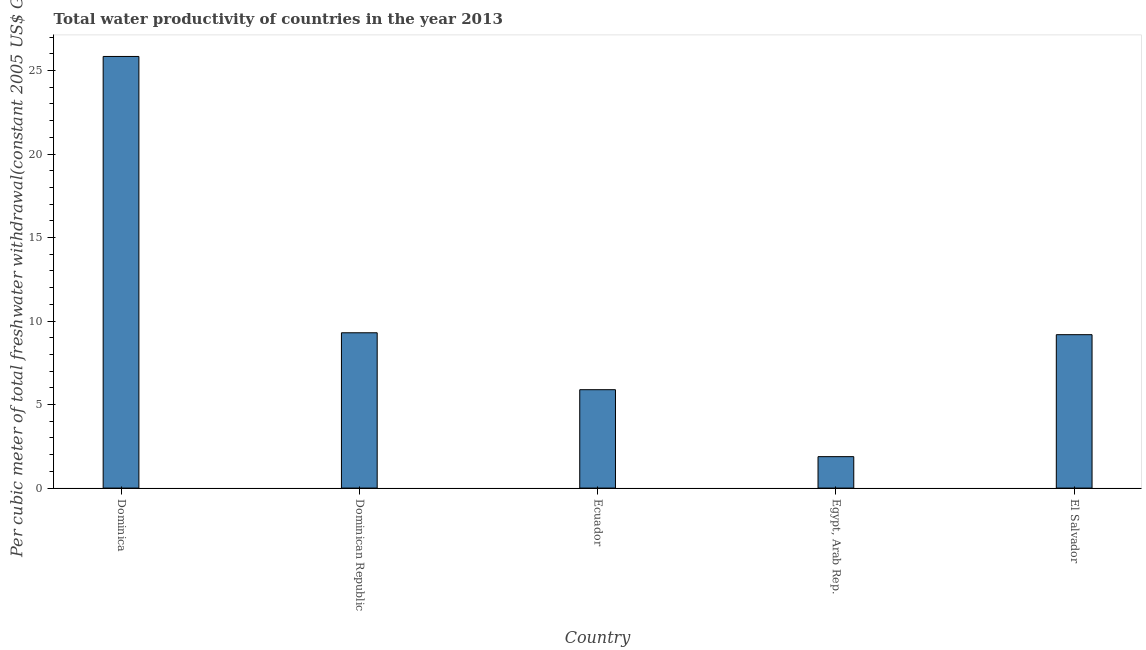Does the graph contain grids?
Your answer should be compact. No. What is the title of the graph?
Provide a succinct answer. Total water productivity of countries in the year 2013. What is the label or title of the Y-axis?
Your answer should be compact. Per cubic meter of total freshwater withdrawal(constant 2005 US$ GDP). What is the total water productivity in Egypt, Arab Rep.?
Make the answer very short. 1.88. Across all countries, what is the maximum total water productivity?
Give a very brief answer. 25.84. Across all countries, what is the minimum total water productivity?
Your answer should be compact. 1.88. In which country was the total water productivity maximum?
Offer a very short reply. Dominica. In which country was the total water productivity minimum?
Your response must be concise. Egypt, Arab Rep. What is the sum of the total water productivity?
Your response must be concise. 52.1. What is the difference between the total water productivity in Dominica and Dominican Republic?
Keep it short and to the point. 16.54. What is the average total water productivity per country?
Your answer should be very brief. 10.42. What is the median total water productivity?
Make the answer very short. 9.18. What is the ratio of the total water productivity in Ecuador to that in Egypt, Arab Rep.?
Provide a short and direct response. 3.13. Is the total water productivity in Dominican Republic less than that in Egypt, Arab Rep.?
Your answer should be compact. No. What is the difference between the highest and the second highest total water productivity?
Your answer should be compact. 16.54. What is the difference between the highest and the lowest total water productivity?
Give a very brief answer. 23.96. In how many countries, is the total water productivity greater than the average total water productivity taken over all countries?
Provide a short and direct response. 1. What is the Per cubic meter of total freshwater withdrawal(constant 2005 US$ GDP) in Dominica?
Your answer should be very brief. 25.84. What is the Per cubic meter of total freshwater withdrawal(constant 2005 US$ GDP) in Dominican Republic?
Offer a very short reply. 9.3. What is the Per cubic meter of total freshwater withdrawal(constant 2005 US$ GDP) in Ecuador?
Provide a short and direct response. 5.89. What is the Per cubic meter of total freshwater withdrawal(constant 2005 US$ GDP) in Egypt, Arab Rep.?
Your response must be concise. 1.88. What is the Per cubic meter of total freshwater withdrawal(constant 2005 US$ GDP) of El Salvador?
Give a very brief answer. 9.18. What is the difference between the Per cubic meter of total freshwater withdrawal(constant 2005 US$ GDP) in Dominica and Dominican Republic?
Provide a succinct answer. 16.54. What is the difference between the Per cubic meter of total freshwater withdrawal(constant 2005 US$ GDP) in Dominica and Ecuador?
Offer a terse response. 19.95. What is the difference between the Per cubic meter of total freshwater withdrawal(constant 2005 US$ GDP) in Dominica and Egypt, Arab Rep.?
Your response must be concise. 23.96. What is the difference between the Per cubic meter of total freshwater withdrawal(constant 2005 US$ GDP) in Dominica and El Salvador?
Keep it short and to the point. 16.66. What is the difference between the Per cubic meter of total freshwater withdrawal(constant 2005 US$ GDP) in Dominican Republic and Ecuador?
Offer a very short reply. 3.41. What is the difference between the Per cubic meter of total freshwater withdrawal(constant 2005 US$ GDP) in Dominican Republic and Egypt, Arab Rep.?
Keep it short and to the point. 7.42. What is the difference between the Per cubic meter of total freshwater withdrawal(constant 2005 US$ GDP) in Dominican Republic and El Salvador?
Keep it short and to the point. 0.11. What is the difference between the Per cubic meter of total freshwater withdrawal(constant 2005 US$ GDP) in Ecuador and Egypt, Arab Rep.?
Your answer should be very brief. 4.01. What is the difference between the Per cubic meter of total freshwater withdrawal(constant 2005 US$ GDP) in Ecuador and El Salvador?
Your answer should be very brief. -3.29. What is the difference between the Per cubic meter of total freshwater withdrawal(constant 2005 US$ GDP) in Egypt, Arab Rep. and El Salvador?
Your answer should be compact. -7.3. What is the ratio of the Per cubic meter of total freshwater withdrawal(constant 2005 US$ GDP) in Dominica to that in Dominican Republic?
Provide a succinct answer. 2.78. What is the ratio of the Per cubic meter of total freshwater withdrawal(constant 2005 US$ GDP) in Dominica to that in Ecuador?
Make the answer very short. 4.39. What is the ratio of the Per cubic meter of total freshwater withdrawal(constant 2005 US$ GDP) in Dominica to that in Egypt, Arab Rep.?
Provide a short and direct response. 13.73. What is the ratio of the Per cubic meter of total freshwater withdrawal(constant 2005 US$ GDP) in Dominica to that in El Salvador?
Provide a succinct answer. 2.81. What is the ratio of the Per cubic meter of total freshwater withdrawal(constant 2005 US$ GDP) in Dominican Republic to that in Ecuador?
Offer a terse response. 1.58. What is the ratio of the Per cubic meter of total freshwater withdrawal(constant 2005 US$ GDP) in Dominican Republic to that in Egypt, Arab Rep.?
Your answer should be compact. 4.94. What is the ratio of the Per cubic meter of total freshwater withdrawal(constant 2005 US$ GDP) in Ecuador to that in Egypt, Arab Rep.?
Make the answer very short. 3.13. What is the ratio of the Per cubic meter of total freshwater withdrawal(constant 2005 US$ GDP) in Ecuador to that in El Salvador?
Make the answer very short. 0.64. What is the ratio of the Per cubic meter of total freshwater withdrawal(constant 2005 US$ GDP) in Egypt, Arab Rep. to that in El Salvador?
Give a very brief answer. 0.2. 